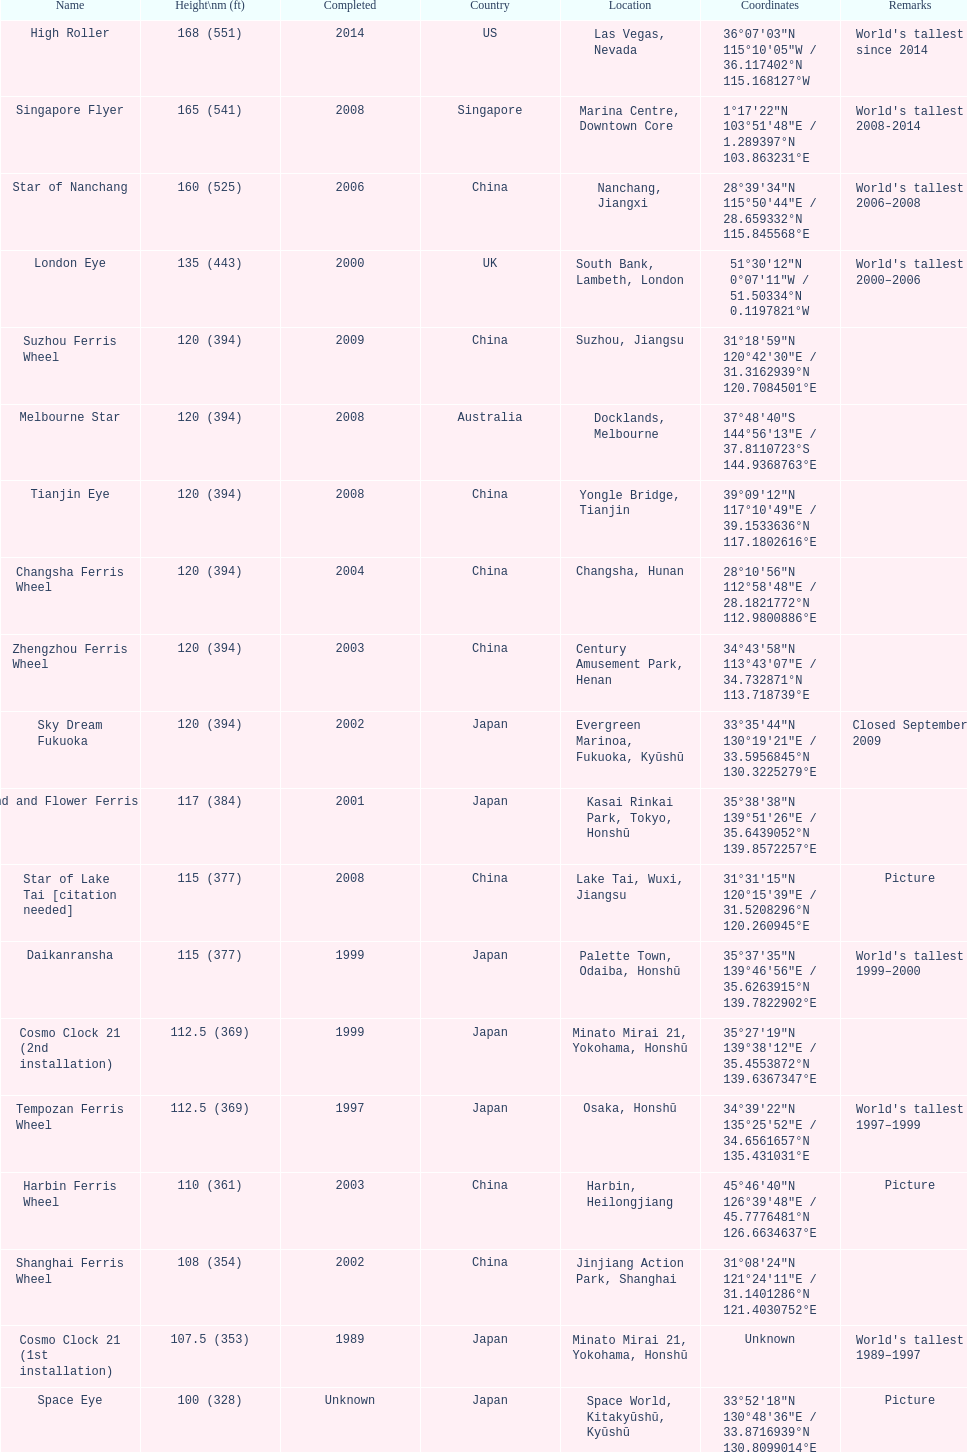Where was the original tallest roller coster built? Chicago. 